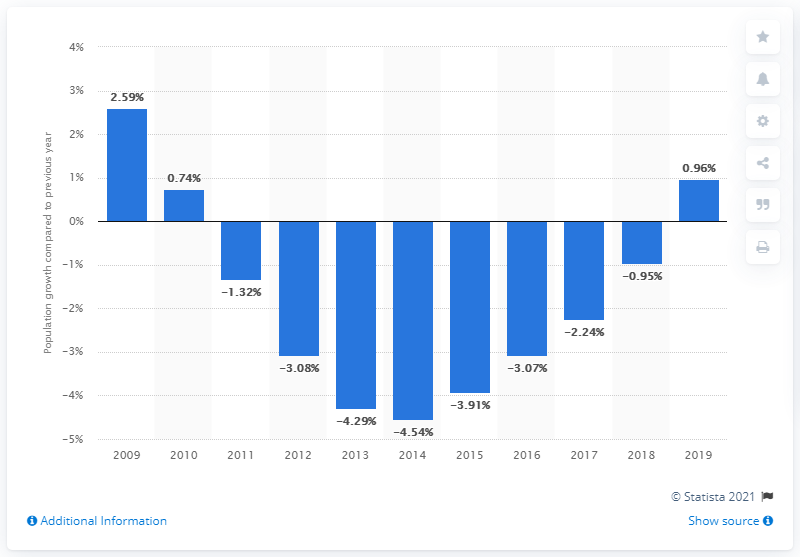Specify some key components in this picture. According to data released in 2019, Syria's population increased by 0.96%. 